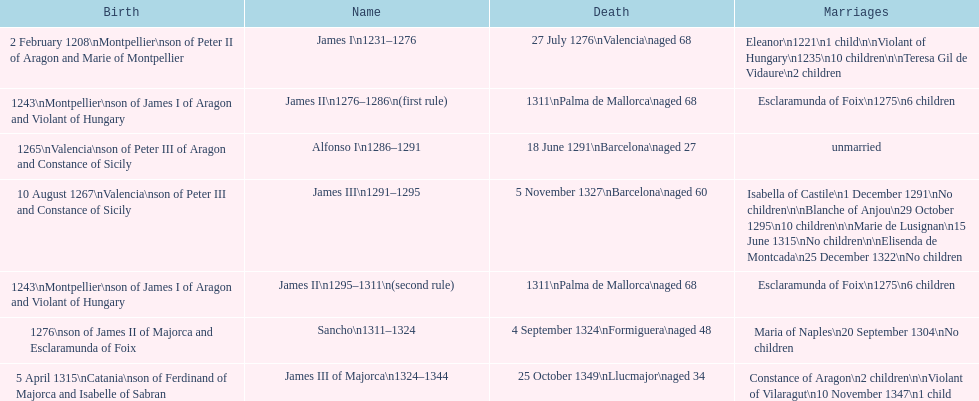Was james iii or sancho born in the year 1276? Sancho. 